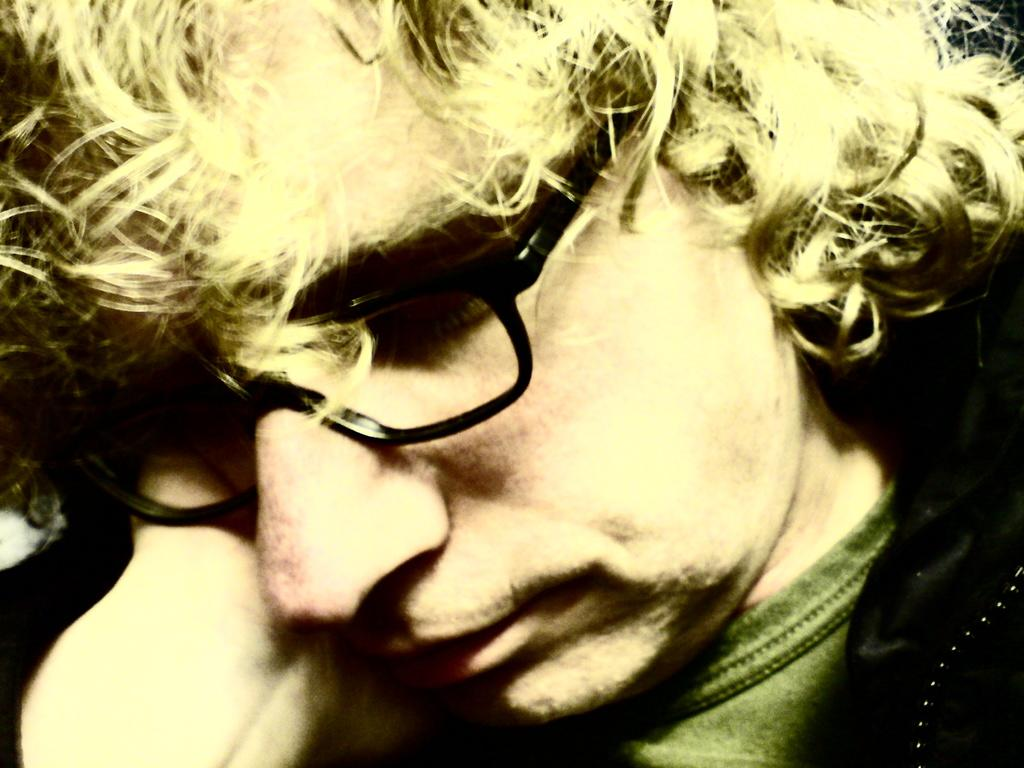Who or what is the main subject of the image? There is a person in the image. What is the person doing in the image? The person is facing the camera. Can you describe any accessories the person is wearing? The person is wearing spectacles. How many snakes are wrapped around the person's neck in the image? There are no snakes present in the image. What type of smile does the person have in the image? The provided facts do not mention the person's facial expression, so we cannot determine if they are smiling or not. 